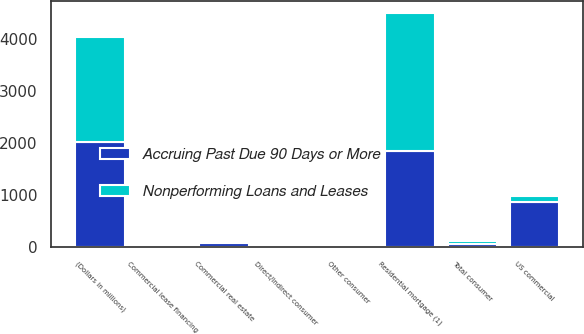Convert chart to OTSL. <chart><loc_0><loc_0><loc_500><loc_500><stacked_bar_chart><ecel><fcel>(Dollars in millions)<fcel>Residential mortgage (1)<fcel>Direct/Indirect consumer<fcel>Other consumer<fcel>Total consumer<fcel>US commercial<fcel>Commercial real estate<fcel>Commercial lease financing<nl><fcel>Accruing Past Due 90 Days or More<fcel>2015<fcel>1845<fcel>24<fcel>1<fcel>66<fcel>867<fcel>93<fcel>12<nl><fcel>Nonperforming Loans and Leases<fcel>2015<fcel>2645<fcel>39<fcel>3<fcel>66<fcel>113<fcel>3<fcel>17<nl></chart> 